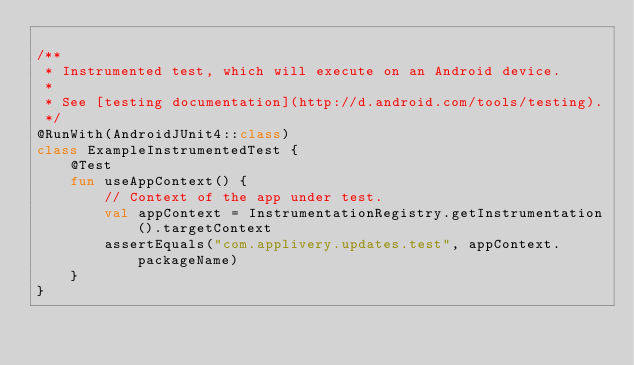Convert code to text. <code><loc_0><loc_0><loc_500><loc_500><_Kotlin_>
/**
 * Instrumented test, which will execute on an Android device.
 *
 * See [testing documentation](http://d.android.com/tools/testing).
 */
@RunWith(AndroidJUnit4::class)
class ExampleInstrumentedTest {
    @Test
    fun useAppContext() {
        // Context of the app under test.
        val appContext = InstrumentationRegistry.getInstrumentation().targetContext
        assertEquals("com.applivery.updates.test", appContext.packageName)
    }
}
</code> 